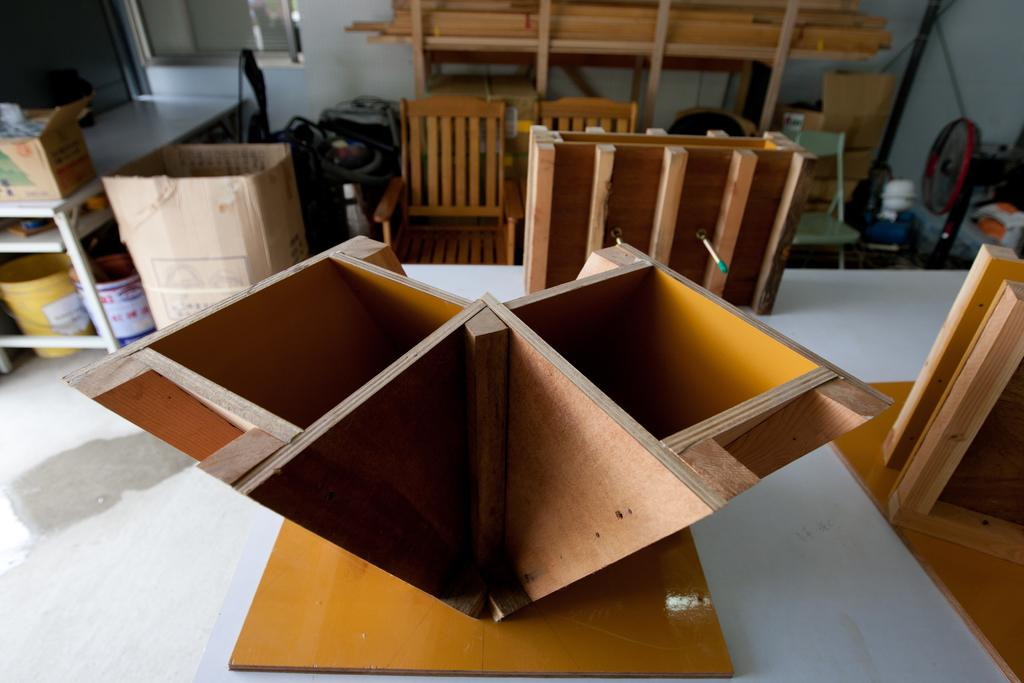Where was the image taken? The image was taken in a room. What furniture is present in the room? There is a table in the room. What type of items can be seen on the table? There are wood items on the table. What is located behind the wood items on the table? There are chairs, cardboard boxes, and a bucket behind the wood items. What other objects are present in the room? Wood sticks and other items are present in the room. What is one of the walls made of in the room? There is a wall in the room. What shape is the camera in the image? There is no camera present in the image. What taste does the wood have in the image? The image does not provide information about the taste of the wood. 